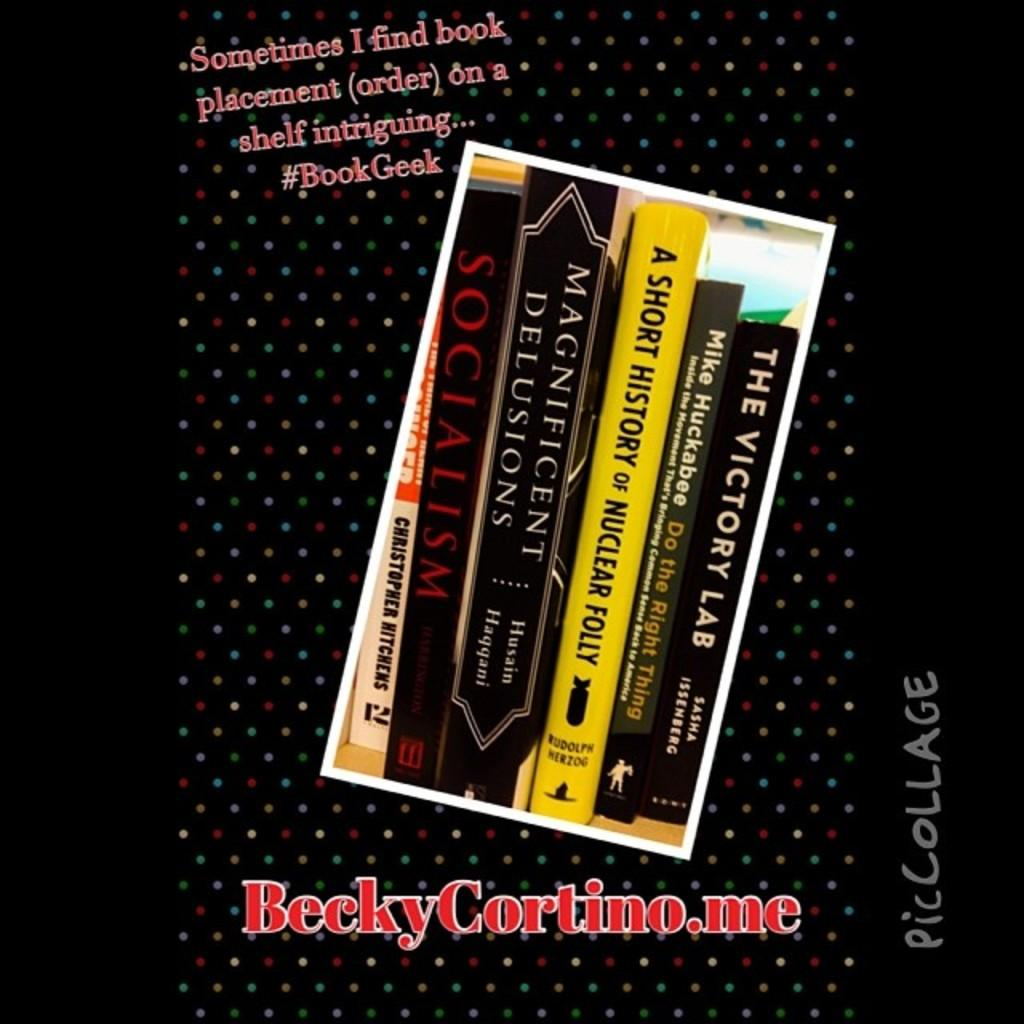<image>
Summarize the visual content of the image. the book cover showing six books of socialism, nuclear folly, victory lab 